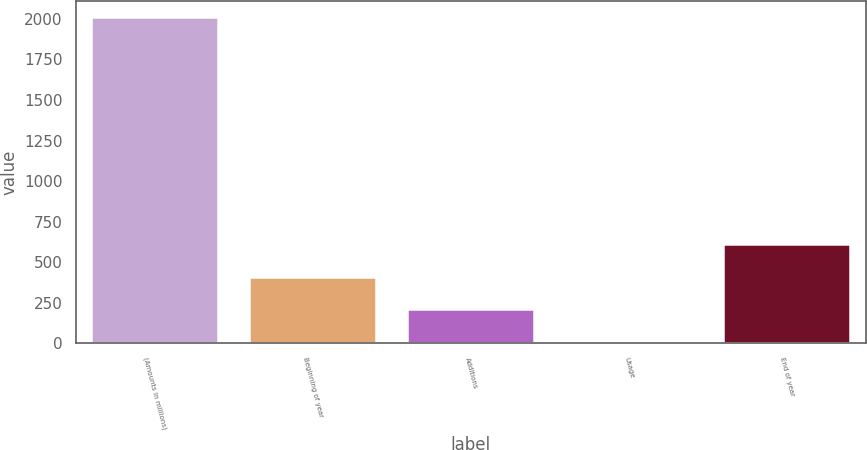<chart> <loc_0><loc_0><loc_500><loc_500><bar_chart><fcel>(Amounts in millions)<fcel>Beginning of year<fcel>Additions<fcel>Usage<fcel>End of year<nl><fcel>2012<fcel>410.48<fcel>210.29<fcel>10.1<fcel>610.67<nl></chart> 